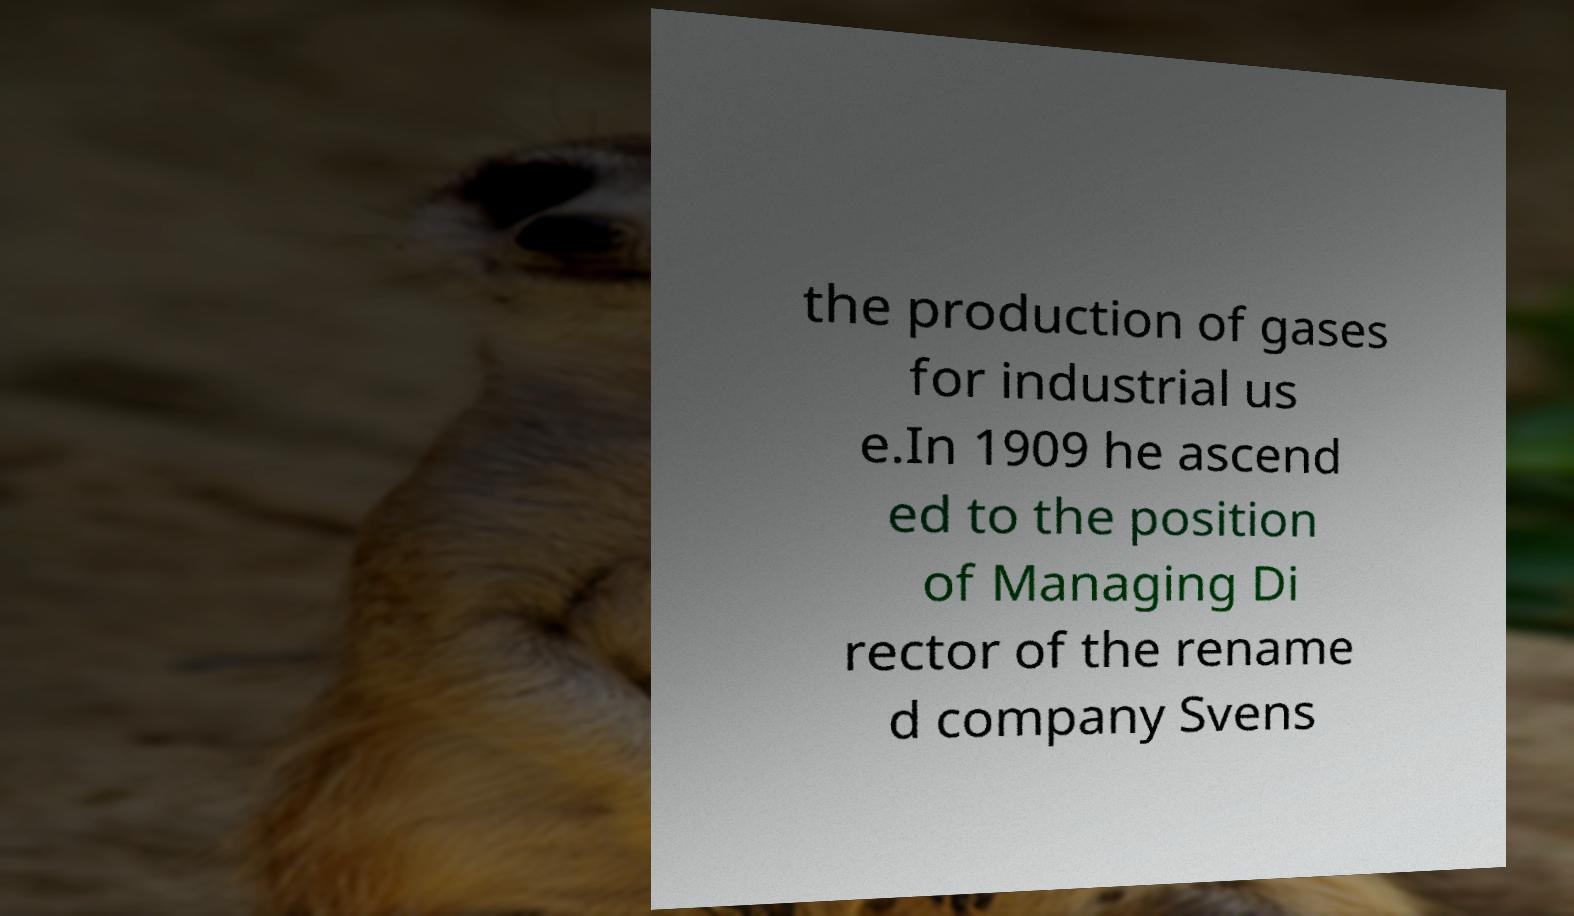Could you extract and type out the text from this image? the production of gases for industrial us e.In 1909 he ascend ed to the position of Managing Di rector of the rename d company Svens 